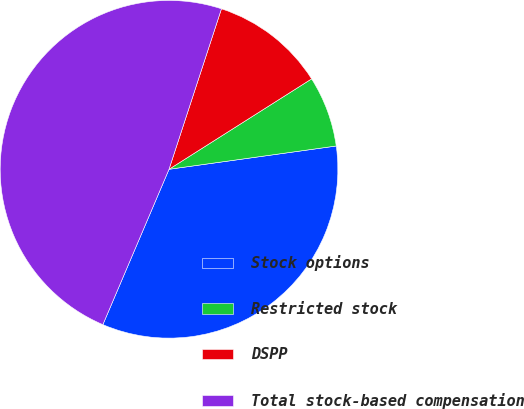Convert chart to OTSL. <chart><loc_0><loc_0><loc_500><loc_500><pie_chart><fcel>Stock options<fcel>Restricted stock<fcel>DSPP<fcel>Total stock-based compensation<nl><fcel>33.61%<fcel>6.79%<fcel>10.98%<fcel>48.62%<nl></chart> 